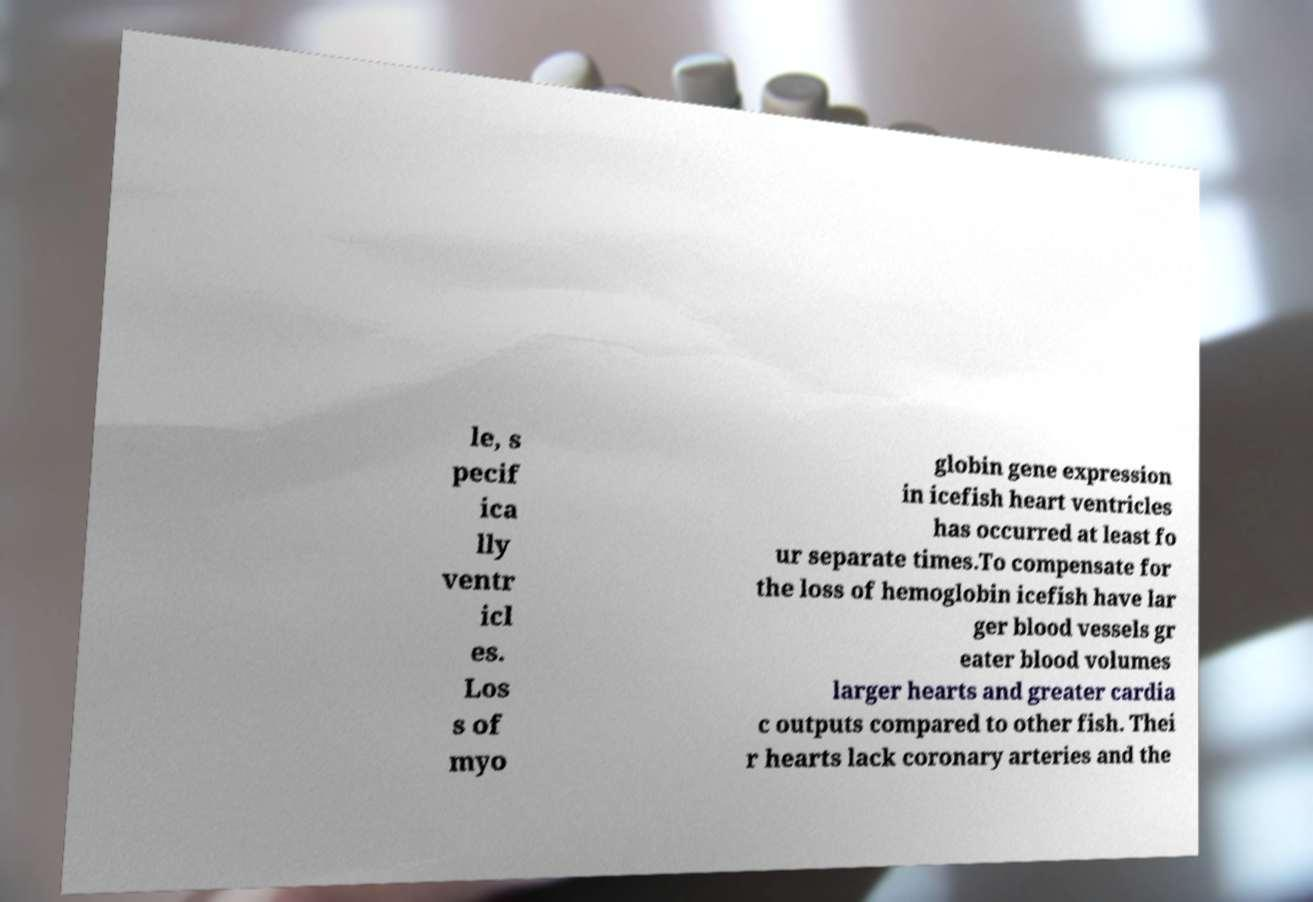I need the written content from this picture converted into text. Can you do that? le, s pecif ica lly ventr icl es. Los s of myo globin gene expression in icefish heart ventricles has occurred at least fo ur separate times.To compensate for the loss of hemoglobin icefish have lar ger blood vessels gr eater blood volumes larger hearts and greater cardia c outputs compared to other fish. Thei r hearts lack coronary arteries and the 